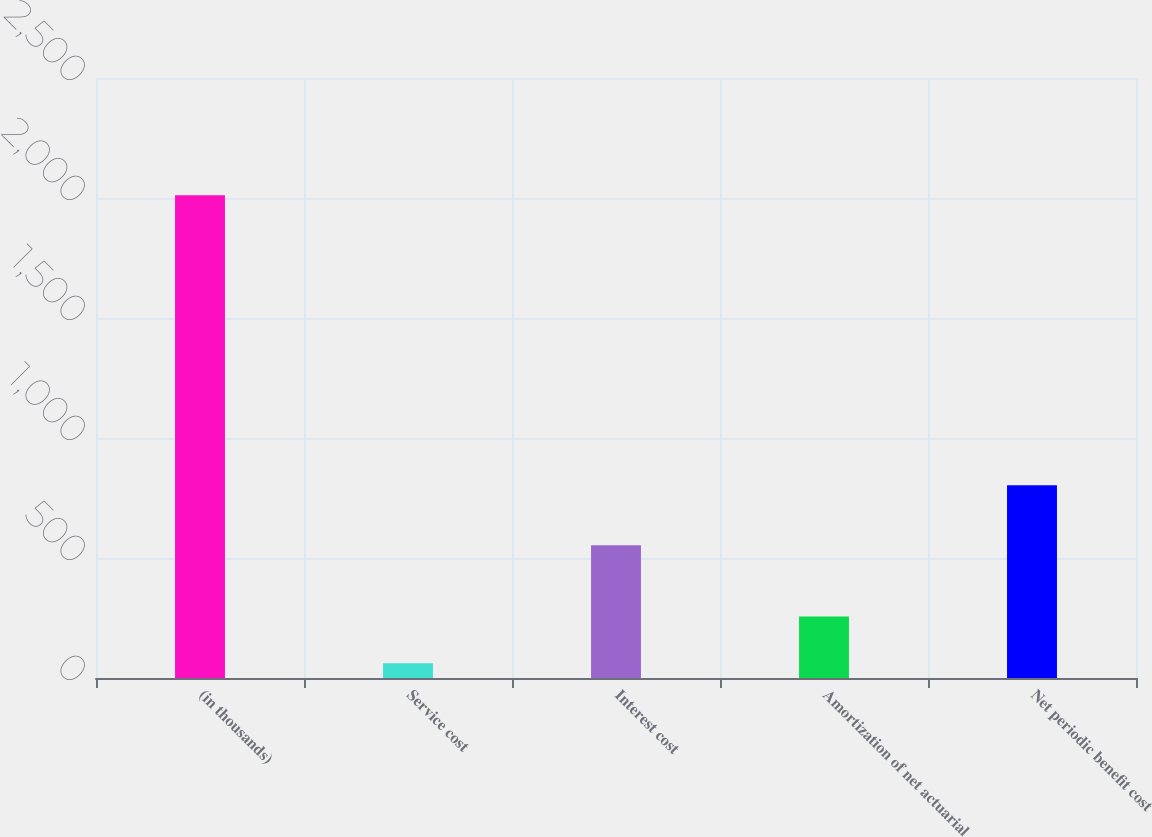<chart> <loc_0><loc_0><loc_500><loc_500><bar_chart><fcel>(in thousands)<fcel>Service cost<fcel>Interest cost<fcel>Amortization of net actuarial<fcel>Net periodic benefit cost<nl><fcel>2011<fcel>61<fcel>553<fcel>256<fcel>803<nl></chart> 